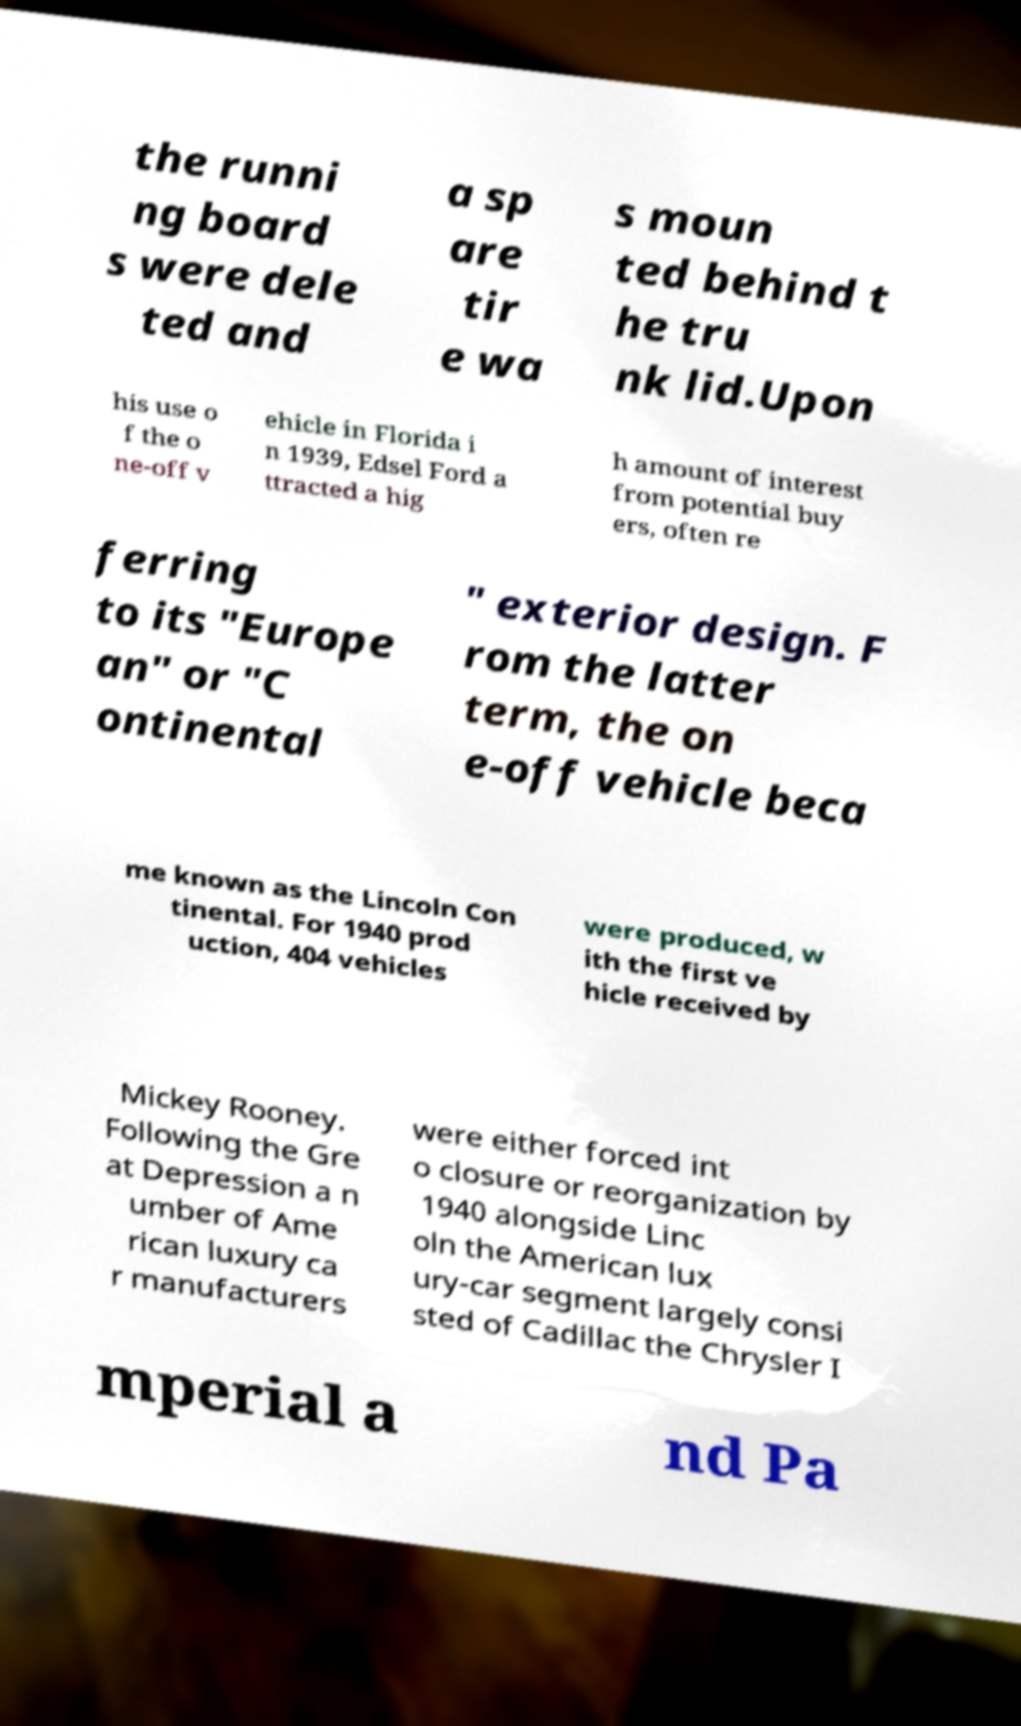Please read and relay the text visible in this image. What does it say? the runni ng board s were dele ted and a sp are tir e wa s moun ted behind t he tru nk lid.Upon his use o f the o ne-off v ehicle in Florida i n 1939, Edsel Ford a ttracted a hig h amount of interest from potential buy ers, often re ferring to its "Europe an" or "C ontinental " exterior design. F rom the latter term, the on e-off vehicle beca me known as the Lincoln Con tinental. For 1940 prod uction, 404 vehicles were produced, w ith the first ve hicle received by Mickey Rooney. Following the Gre at Depression a n umber of Ame rican luxury ca r manufacturers were either forced int o closure or reorganization by 1940 alongside Linc oln the American lux ury-car segment largely consi sted of Cadillac the Chrysler I mperial a nd Pa 